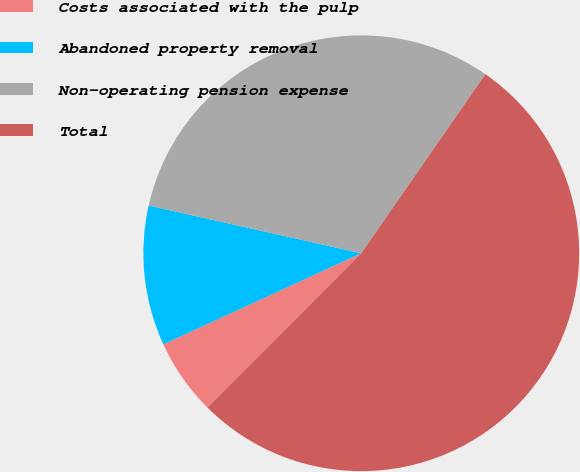Convert chart. <chart><loc_0><loc_0><loc_500><loc_500><pie_chart><fcel>Costs associated with the pulp<fcel>Abandoned property removal<fcel>Non-operating pension expense<fcel>Total<nl><fcel>5.66%<fcel>10.38%<fcel>31.13%<fcel>52.83%<nl></chart> 